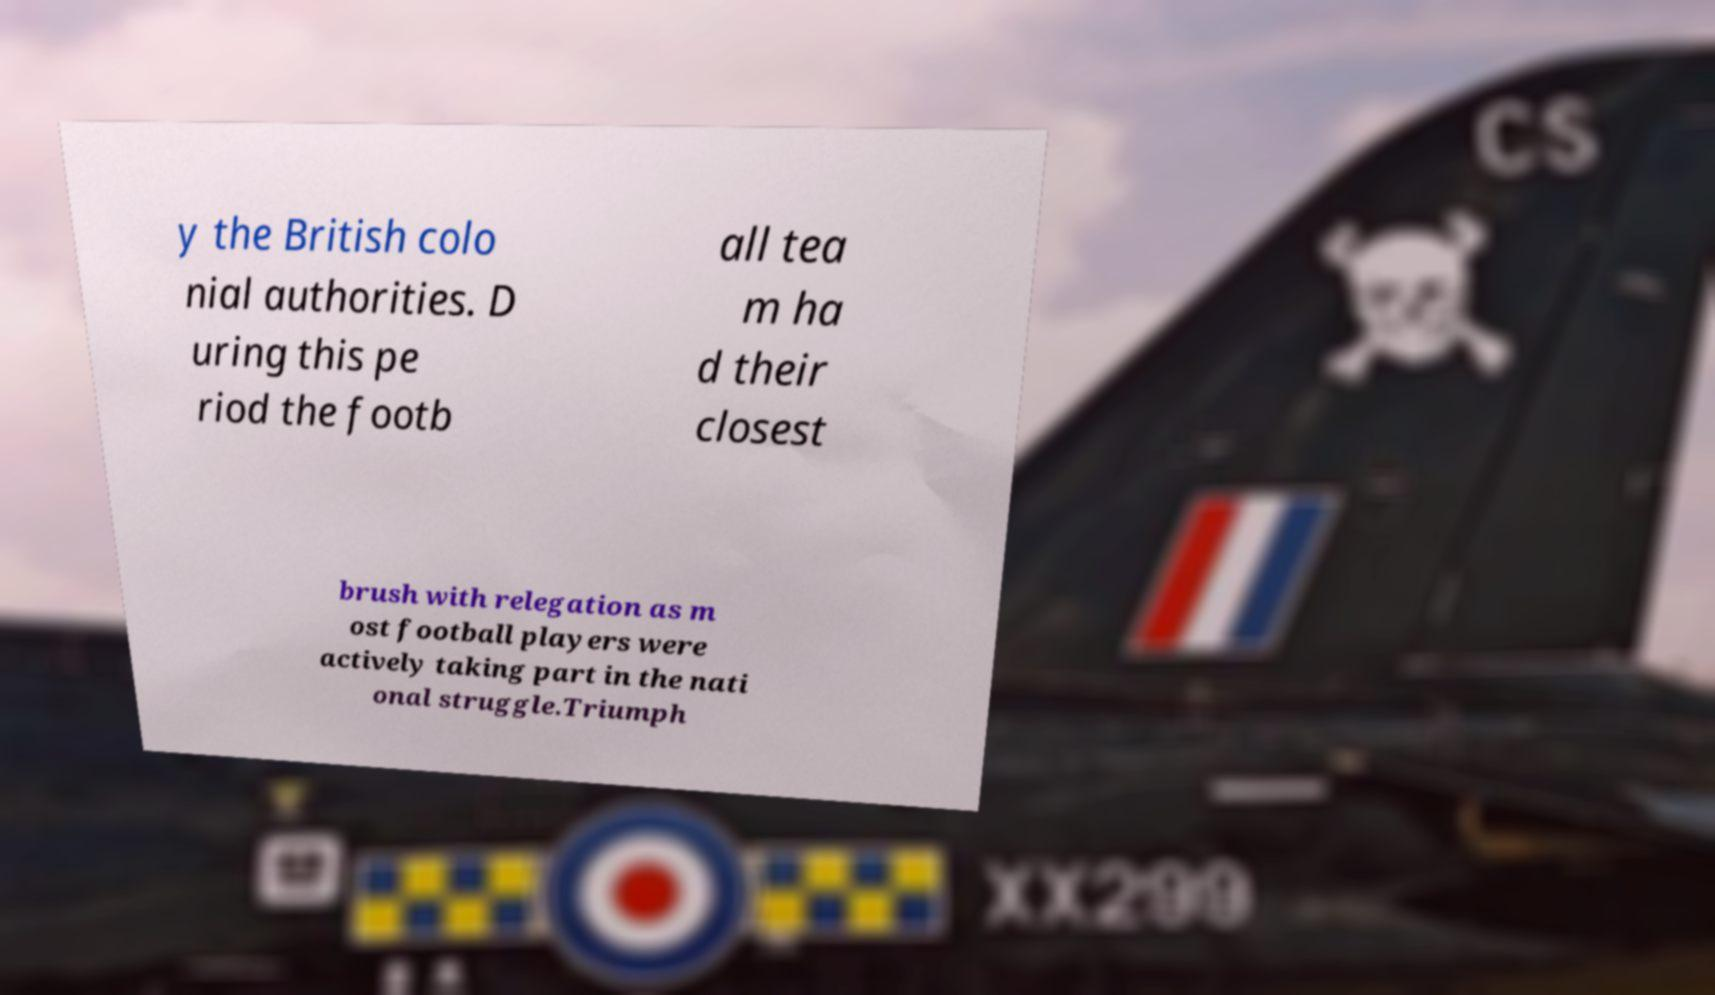I need the written content from this picture converted into text. Can you do that? y the British colo nial authorities. D uring this pe riod the footb all tea m ha d their closest brush with relegation as m ost football players were actively taking part in the nati onal struggle.Triumph 